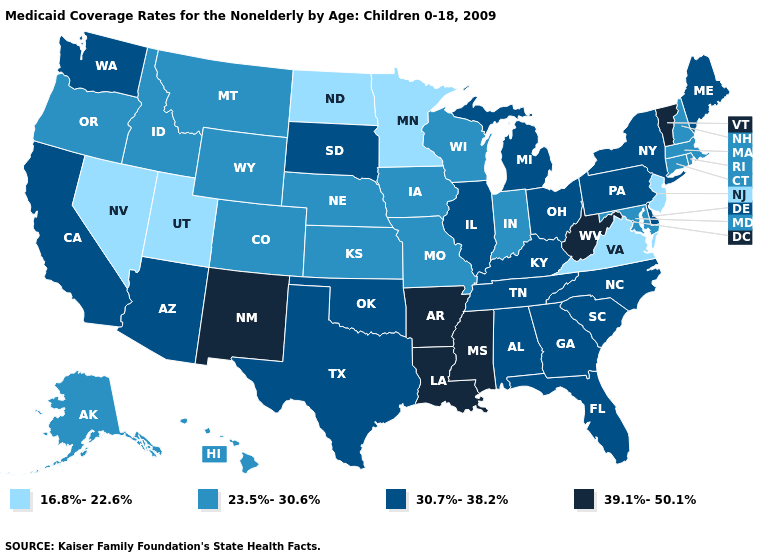Name the states that have a value in the range 39.1%-50.1%?
Be succinct. Arkansas, Louisiana, Mississippi, New Mexico, Vermont, West Virginia. Does California have a lower value than Michigan?
Concise answer only. No. What is the value of Missouri?
Concise answer only. 23.5%-30.6%. Among the states that border Washington , which have the highest value?
Quick response, please. Idaho, Oregon. Name the states that have a value in the range 23.5%-30.6%?
Write a very short answer. Alaska, Colorado, Connecticut, Hawaii, Idaho, Indiana, Iowa, Kansas, Maryland, Massachusetts, Missouri, Montana, Nebraska, New Hampshire, Oregon, Rhode Island, Wisconsin, Wyoming. What is the value of Montana?
Concise answer only. 23.5%-30.6%. What is the highest value in the South ?
Quick response, please. 39.1%-50.1%. What is the value of Indiana?
Concise answer only. 23.5%-30.6%. Does Montana have the same value as Arkansas?
Short answer required. No. What is the value of Wyoming?
Keep it brief. 23.5%-30.6%. Name the states that have a value in the range 39.1%-50.1%?
Keep it brief. Arkansas, Louisiana, Mississippi, New Mexico, Vermont, West Virginia. What is the value of Illinois?
Keep it brief. 30.7%-38.2%. Name the states that have a value in the range 39.1%-50.1%?
Quick response, please. Arkansas, Louisiana, Mississippi, New Mexico, Vermont, West Virginia. How many symbols are there in the legend?
Give a very brief answer. 4. Does Georgia have a lower value than West Virginia?
Write a very short answer. Yes. 